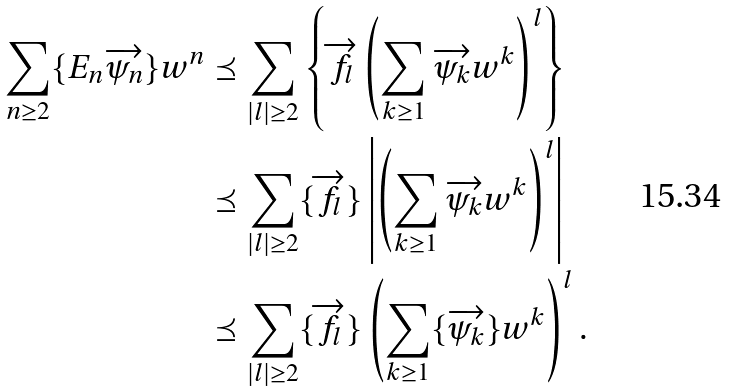Convert formula to latex. <formula><loc_0><loc_0><loc_500><loc_500>\sum _ { n \geq 2 } \{ E _ { n } \overrightarrow { \psi _ { n } } \} w ^ { n } & \preceq \sum _ { | l | \geq 2 } \left \{ \overrightarrow { f _ { l } } \left ( \sum _ { k \geq 1 } \overrightarrow { \psi _ { k } } w ^ { k } \right ) ^ { l } \right \} \\ & \preceq \sum _ { | l | \geq 2 } \{ \overrightarrow { f _ { l } } \} \left | \left ( \sum _ { k \geq 1 } \overrightarrow { \psi _ { k } } w ^ { k } \right ) ^ { l } \right | \\ & \preceq \sum _ { | l | \geq 2 } \{ \overrightarrow { f _ { l } } \} \left ( \sum _ { k \geq 1 } \{ \overrightarrow { \psi _ { k } } \} w ^ { k } \right ) ^ { l } .</formula> 